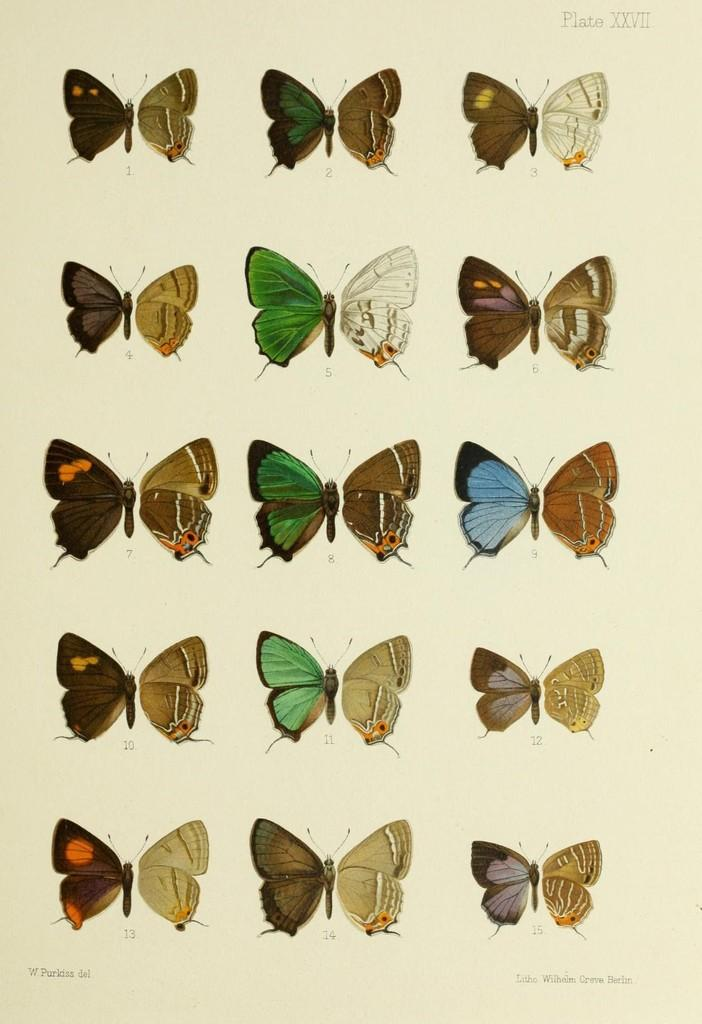What is present on the paper in the image? The paper has butterflies on it. What else can be seen on the paper? There is writing on the paper. What type of health advice is written on the paper in the image? There is no health advice present on the paper in the image; it only has butterflies and writing. 